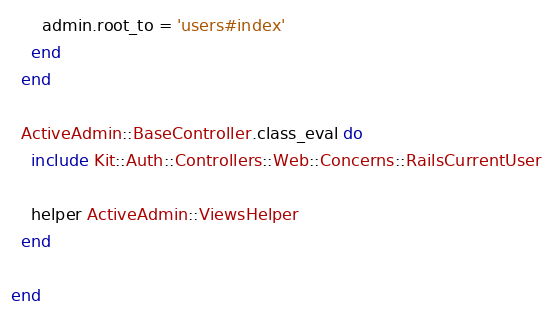Convert code to text. <code><loc_0><loc_0><loc_500><loc_500><_Ruby_>      admin.root_to = 'users#index'
    end
  end

  ActiveAdmin::BaseController.class_eval do
    include Kit::Auth::Controllers::Web::Concerns::RailsCurrentUser

    helper ActiveAdmin::ViewsHelper
  end

end
</code> 